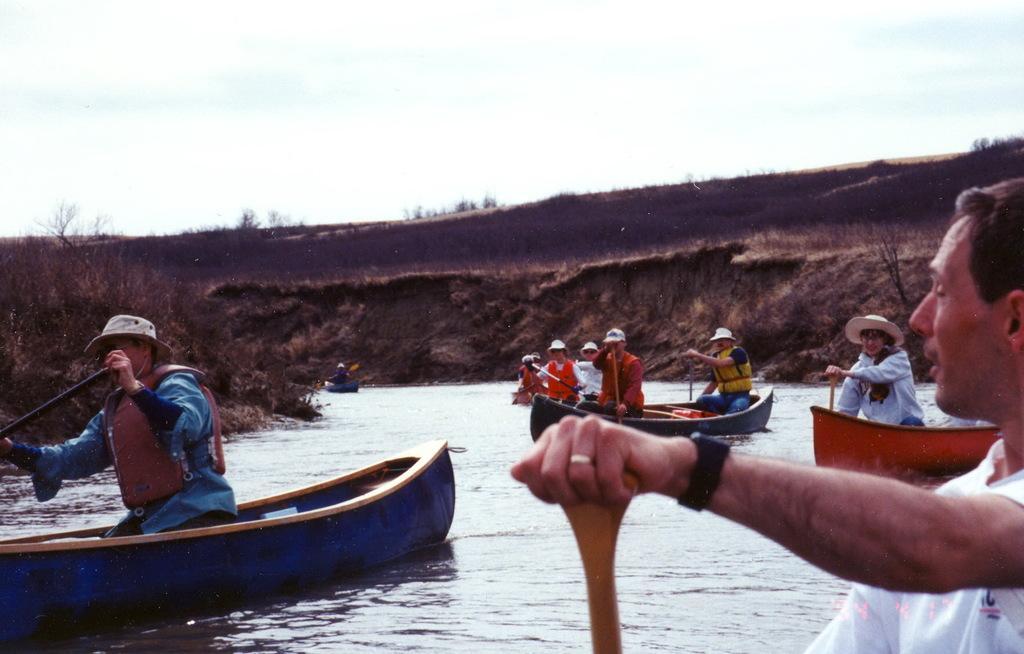Could you give a brief overview of what you see in this image? In this picture we can see boats on the water with some people sitting in it and holding paddles with their hands. In the background we can see planets on the ground, trees and the sky. 